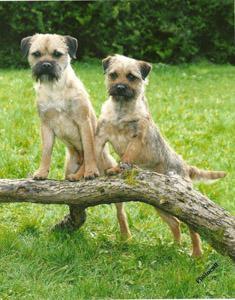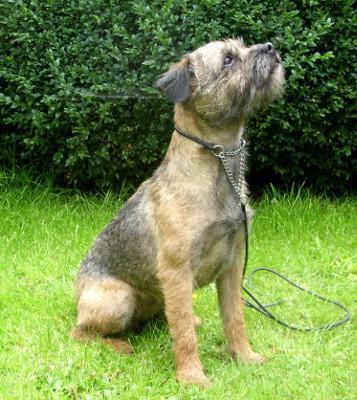The first image is the image on the left, the second image is the image on the right. Examine the images to the left and right. Is the description "An image shows two dogs together outdoors, and at least one dog is standing with its front paws balanced on something for support." accurate? Answer yes or no. Yes. The first image is the image on the left, the second image is the image on the right. Examine the images to the left and right. Is the description "The dog in the image on the left is running through the grass." accurate? Answer yes or no. No. 